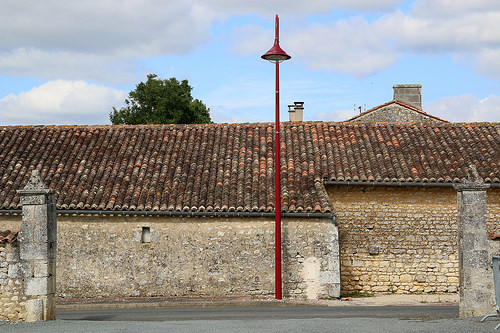<image>
Can you confirm if the building is behind the tree? No. The building is not behind the tree. From this viewpoint, the building appears to be positioned elsewhere in the scene. 